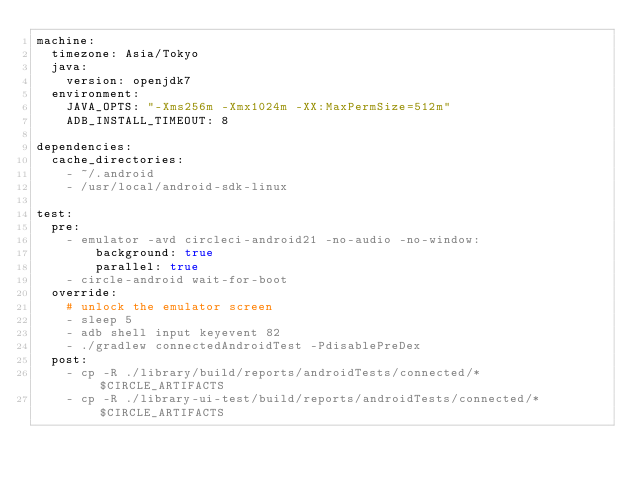Convert code to text. <code><loc_0><loc_0><loc_500><loc_500><_YAML_>machine:
  timezone: Asia/Tokyo
  java:
    version: openjdk7
  environment:
    JAVA_OPTS: "-Xms256m -Xmx1024m -XX:MaxPermSize=512m"
    ADB_INSTALL_TIMEOUT: 8

dependencies:
  cache_directories:
    - ~/.android
    - /usr/local/android-sdk-linux

test:
  pre:
    - emulator -avd circleci-android21 -no-audio -no-window:
        background: true
        parallel: true
    - circle-android wait-for-boot
  override:
    # unlock the emulator screen
    - sleep 5
    - adb shell input keyevent 82
    - ./gradlew connectedAndroidTest -PdisablePreDex
  post:
    - cp -R ./library/build/reports/androidTests/connected/* $CIRCLE_ARTIFACTS
    - cp -R ./library-ui-test/build/reports/androidTests/connected/* $CIRCLE_ARTIFACTS</code> 